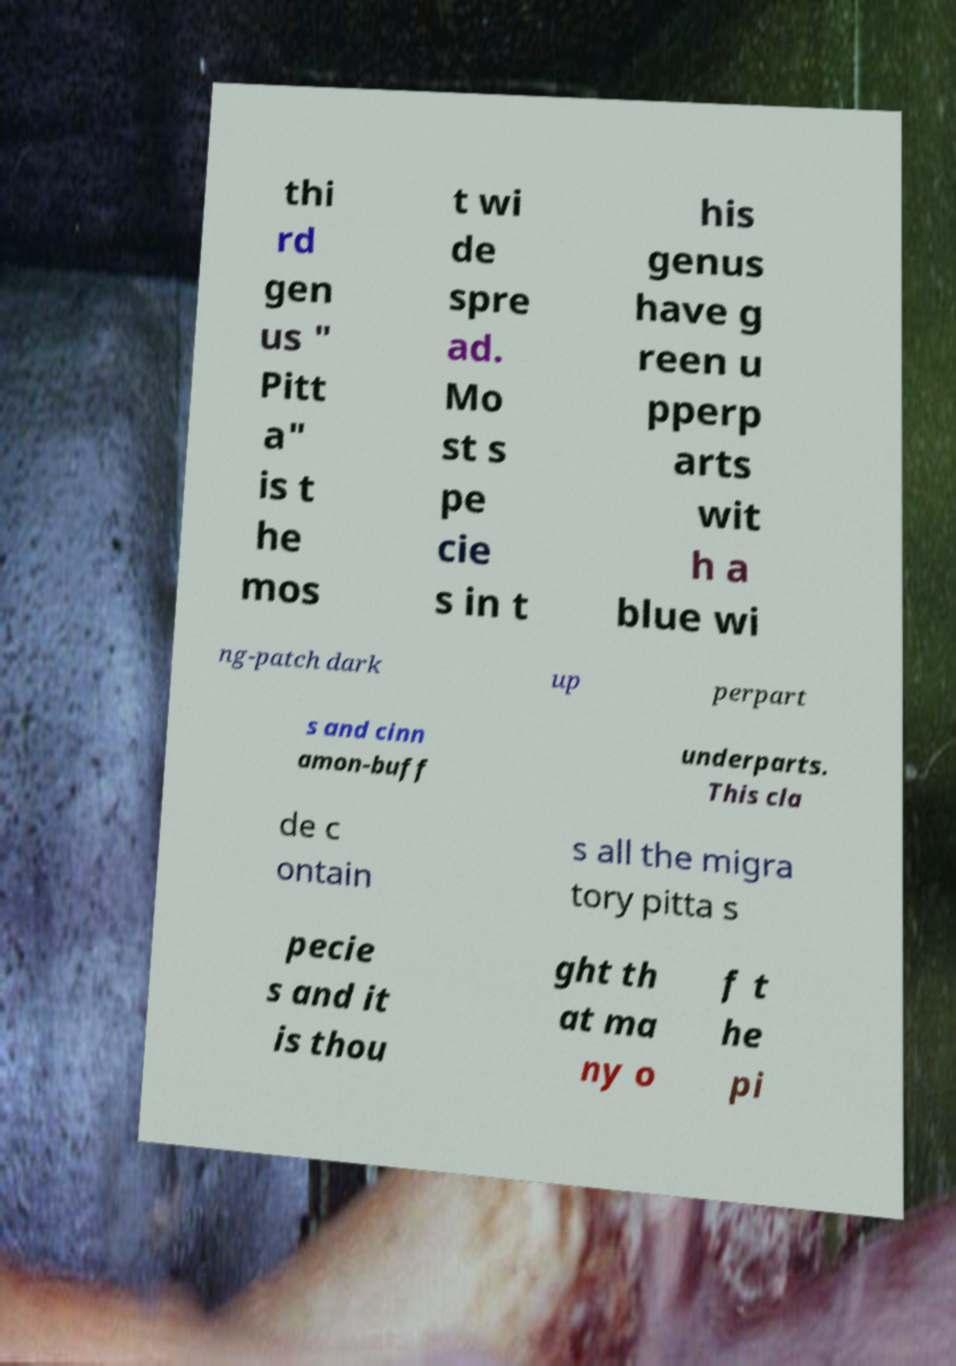Could you extract and type out the text from this image? thi rd gen us " Pitt a" is t he mos t wi de spre ad. Mo st s pe cie s in t his genus have g reen u pperp arts wit h a blue wi ng-patch dark up perpart s and cinn amon-buff underparts. This cla de c ontain s all the migra tory pitta s pecie s and it is thou ght th at ma ny o f t he pi 